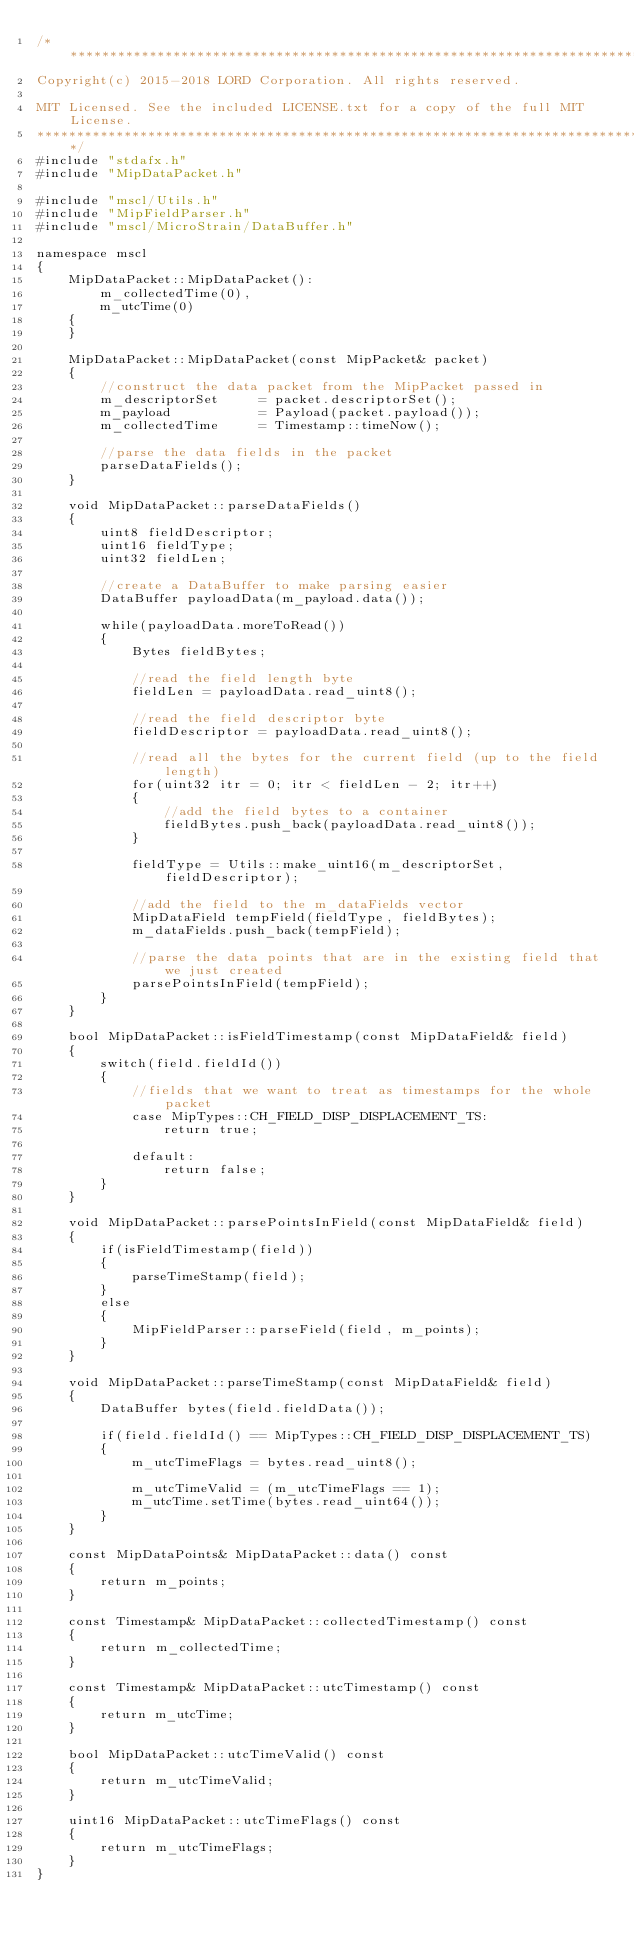<code> <loc_0><loc_0><loc_500><loc_500><_C++_>/*******************************************************************************
Copyright(c) 2015-2018 LORD Corporation. All rights reserved.

MIT Licensed. See the included LICENSE.txt for a copy of the full MIT License.
*******************************************************************************/
#include "stdafx.h"
#include "MipDataPacket.h"

#include "mscl/Utils.h"
#include "MipFieldParser.h"
#include "mscl/MicroStrain/DataBuffer.h"

namespace mscl
{                    
    MipDataPacket::MipDataPacket():
        m_collectedTime(0),
        m_utcTime(0)
    {
    }

    MipDataPacket::MipDataPacket(const MipPacket& packet)
    {
        //construct the data packet from the MipPacket passed in
        m_descriptorSet     = packet.descriptorSet();
        m_payload           = Payload(packet.payload());
        m_collectedTime     = Timestamp::timeNow();

        //parse the data fields in the packet
        parseDataFields();
    }

    void MipDataPacket::parseDataFields()
    {
        uint8 fieldDescriptor;
        uint16 fieldType;
        uint32 fieldLen;

        //create a DataBuffer to make parsing easier
        DataBuffer payloadData(m_payload.data());

        while(payloadData.moreToRead())
        {
            Bytes fieldBytes;

            //read the field length byte
            fieldLen = payloadData.read_uint8();

            //read the field descriptor byte
            fieldDescriptor = payloadData.read_uint8();

            //read all the bytes for the current field (up to the field length)
            for(uint32 itr = 0; itr < fieldLen - 2; itr++)
            {
                //add the field bytes to a container
                fieldBytes.push_back(payloadData.read_uint8());
            } 

            fieldType = Utils::make_uint16(m_descriptorSet, fieldDescriptor);

            //add the field to the m_dataFields vector
            MipDataField tempField(fieldType, fieldBytes);
            m_dataFields.push_back(tempField);

            //parse the data points that are in the existing field that we just created
            parsePointsInField(tempField);
        }
    }

    bool MipDataPacket::isFieldTimestamp(const MipDataField& field)
    {
        switch(field.fieldId())
        {
            //fields that we want to treat as timestamps for the whole packet
            case MipTypes::CH_FIELD_DISP_DISPLACEMENT_TS:
                return true;

            default:
                return false;
        }
    }

    void MipDataPacket::parsePointsInField(const MipDataField& field)
    {
        if(isFieldTimestamp(field))
        {
            parseTimeStamp(field);
        }
        else
        {
            MipFieldParser::parseField(field, m_points);
        }
    }

    void MipDataPacket::parseTimeStamp(const MipDataField& field)
    {
        DataBuffer bytes(field.fieldData());

        if(field.fieldId() == MipTypes::CH_FIELD_DISP_DISPLACEMENT_TS)
        {
            m_utcTimeFlags = bytes.read_uint8();

            m_utcTimeValid = (m_utcTimeFlags == 1);
            m_utcTime.setTime(bytes.read_uint64());
        }
    }

    const MipDataPoints& MipDataPacket::data() const
    {
        return m_points;
    }

    const Timestamp& MipDataPacket::collectedTimestamp() const
    {
        return m_collectedTime;
    }

    const Timestamp& MipDataPacket::utcTimestamp() const
    {
        return m_utcTime;
    }

    bool MipDataPacket::utcTimeValid() const
    {
        return m_utcTimeValid;
    }

    uint16 MipDataPacket::utcTimeFlags() const
    {
        return m_utcTimeFlags;
    }
}</code> 